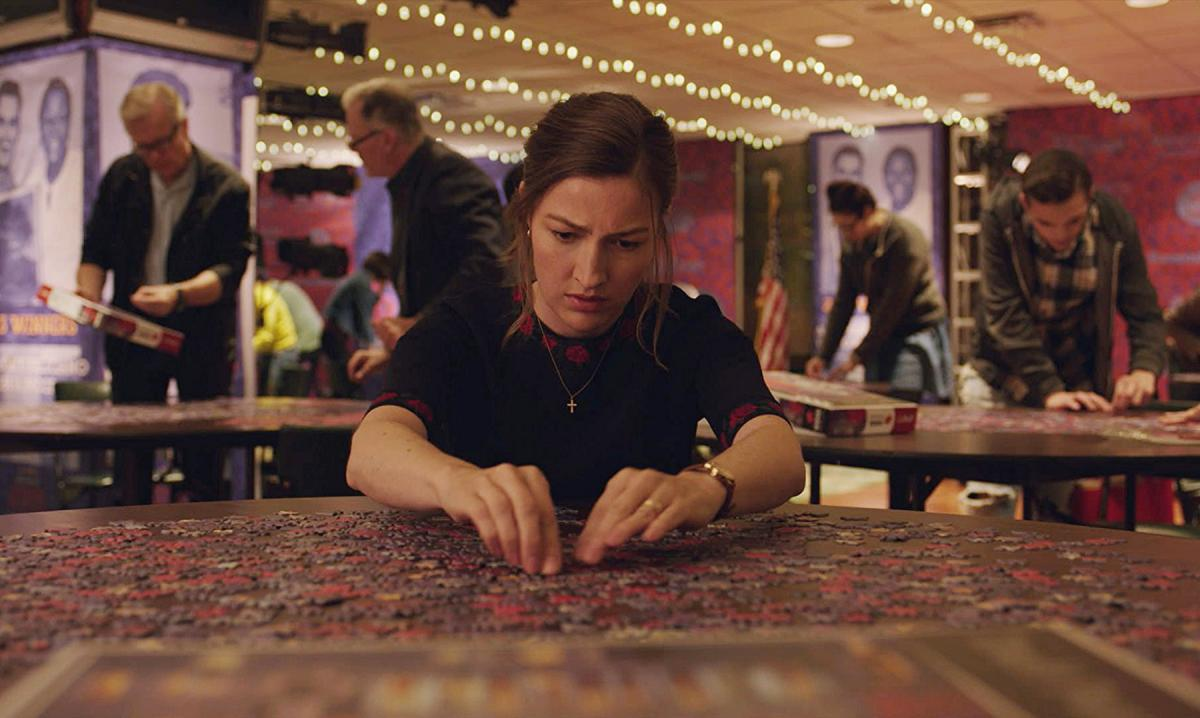What's happening in the scene? In the image, a woman is deeply engrossed in assembling a puzzle. She sits at a table laden with scattered puzzle pieces, showing a scene of active engagement and concentration. She is dressed in a dark top with distinctive red accents, creating a pop of color that draws the eye. The background features softly glowing lights and blurred figures of other people, suggesting a communal or public space, possibly during an event or gathering focused on puzzle games. This environment underscores a sense of community and shared interest in the puzzle activity. 